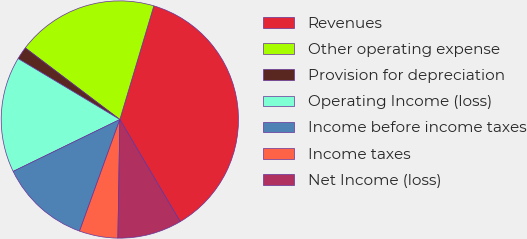<chart> <loc_0><loc_0><loc_500><loc_500><pie_chart><fcel>Revenues<fcel>Other operating expense<fcel>Provision for depreciation<fcel>Operating Income (loss)<fcel>Income before income taxes<fcel>Income taxes<fcel>Net Income (loss)<nl><fcel>36.88%<fcel>19.31%<fcel>1.73%<fcel>15.79%<fcel>12.28%<fcel>5.25%<fcel>8.76%<nl></chart> 